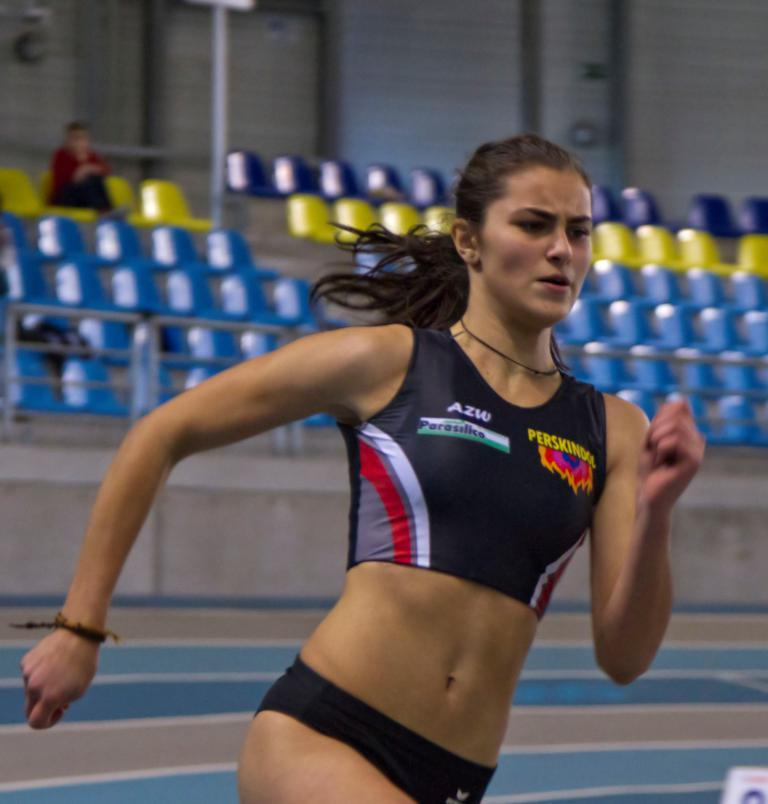<image>
Give a short and clear explanation of the subsequent image. A female track star with the last name of Perskindol 